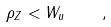Convert formula to latex. <formula><loc_0><loc_0><loc_500><loc_500>\rho _ { Z } < W _ { u } \quad ,</formula> 